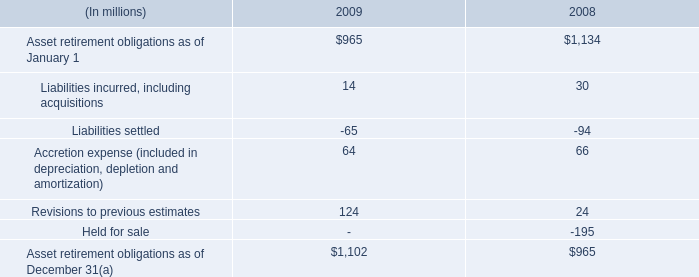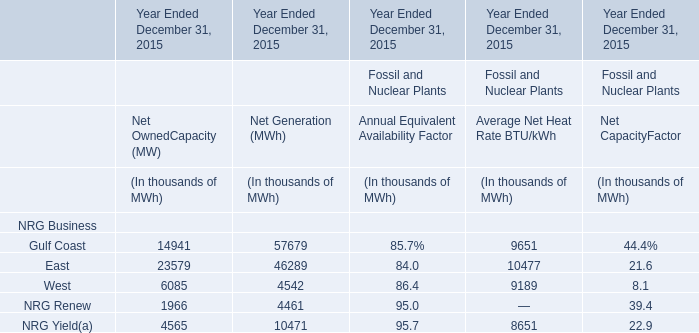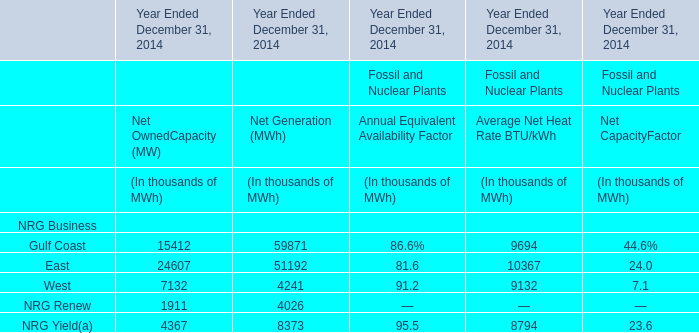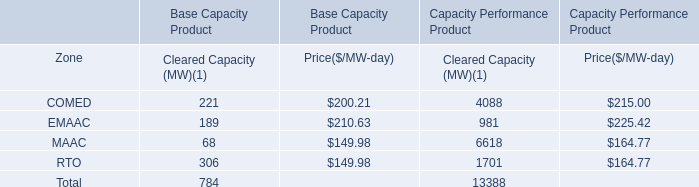by what percentage did asset retirement obligations decrease from 2007 to 2008? 
Computations: ((965 - 1134) / 1134)
Answer: -0.14903. 